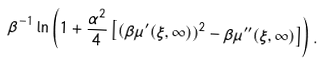<formula> <loc_0><loc_0><loc_500><loc_500>\beta ^ { - 1 } \ln \left ( 1 + \frac { \alpha ^ { 2 } } { 4 } \left [ ( \beta \mu ^ { \prime } ( \xi , \infty ) ) ^ { 2 } - \beta \mu ^ { \prime \prime } ( \xi , \infty ) \right ] \right ) .</formula> 